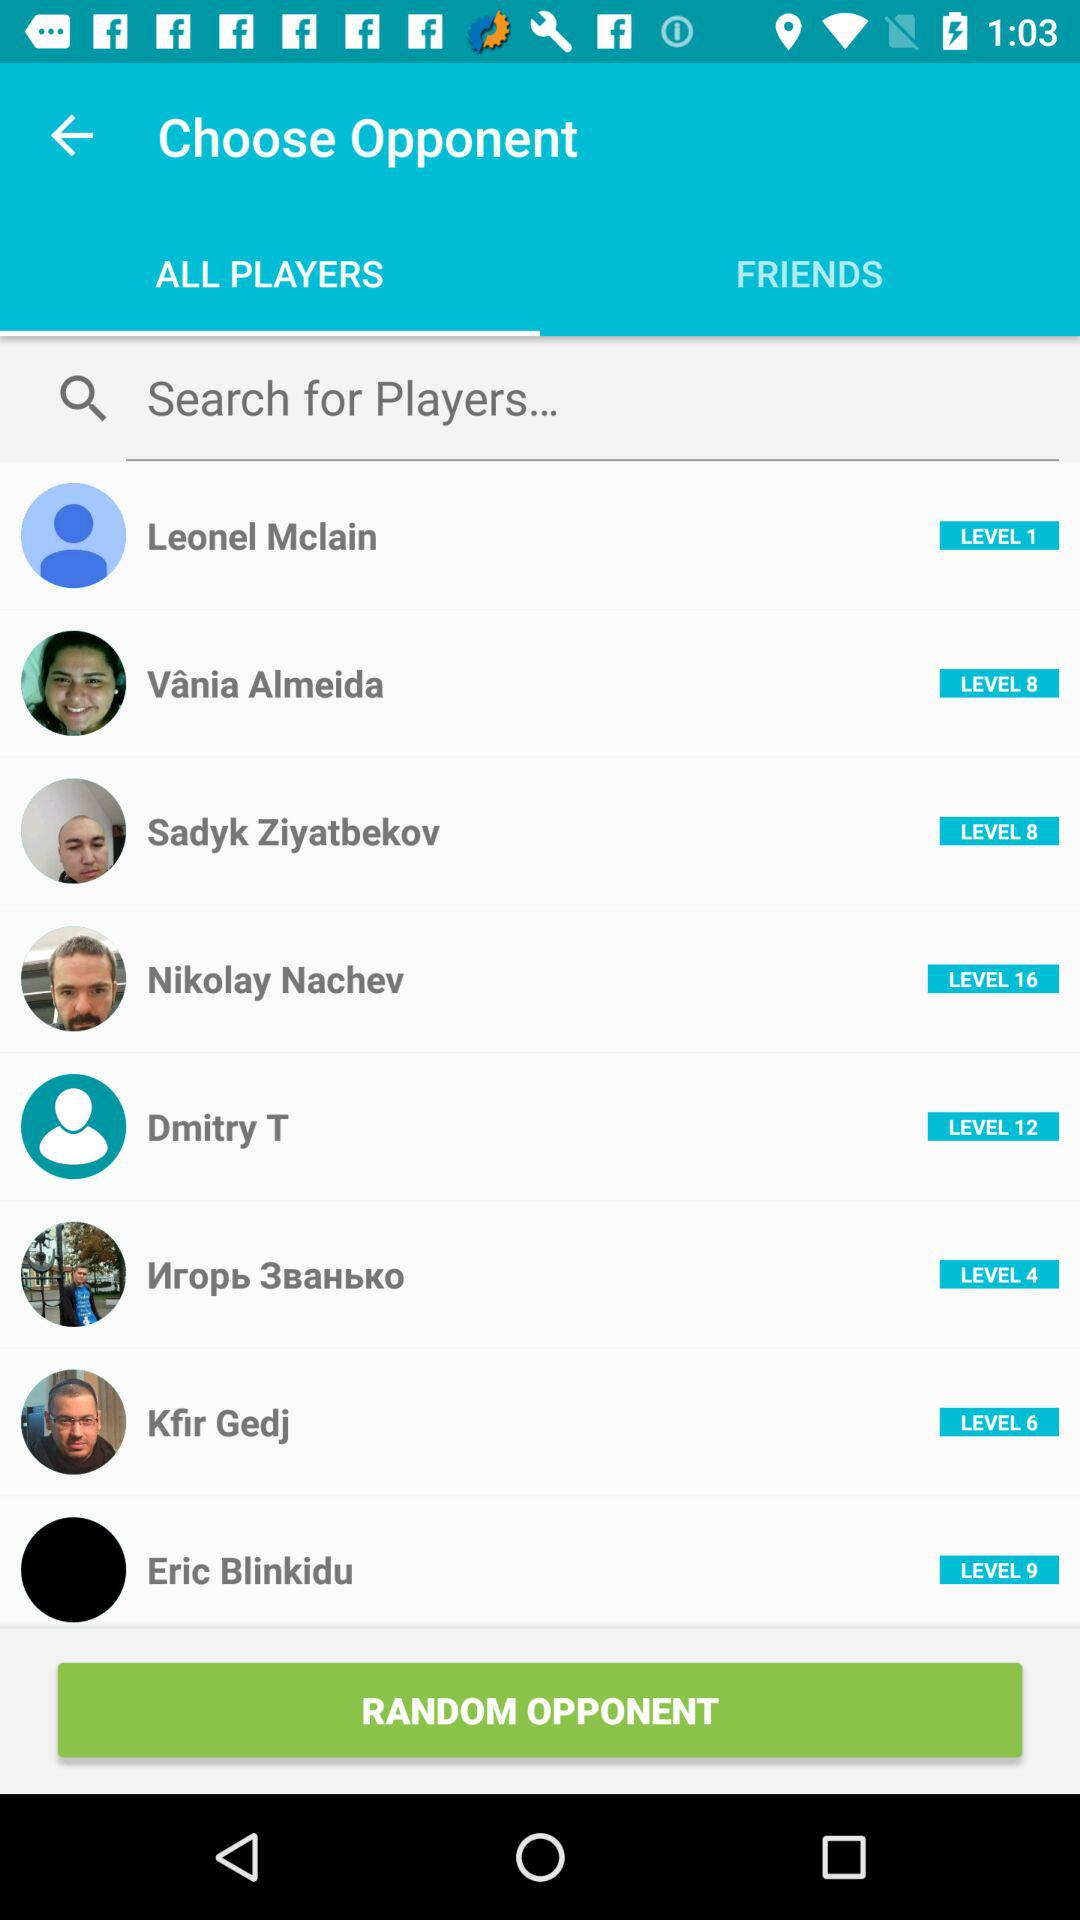What player is at "Level 1"? The player who is at "Level 1" is Leonel Mclain. 